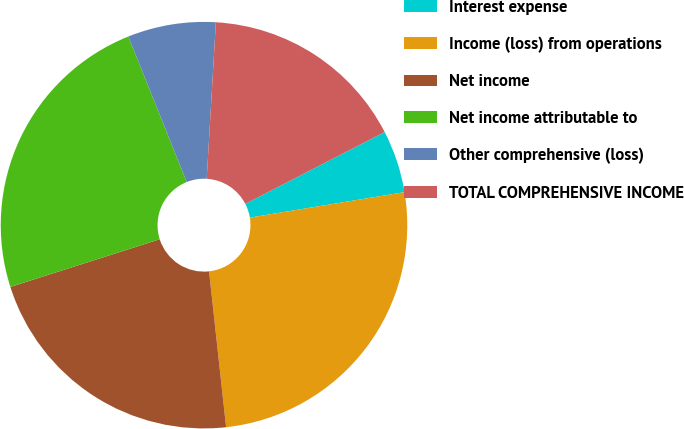Convert chart to OTSL. <chart><loc_0><loc_0><loc_500><loc_500><pie_chart><fcel>Interest expense<fcel>Income (loss) from operations<fcel>Net income<fcel>Net income attributable to<fcel>Other comprehensive (loss)<fcel>TOTAL COMPREHENSIVE INCOME<nl><fcel>4.98%<fcel>25.86%<fcel>21.82%<fcel>23.84%<fcel>7.0%<fcel>16.49%<nl></chart> 